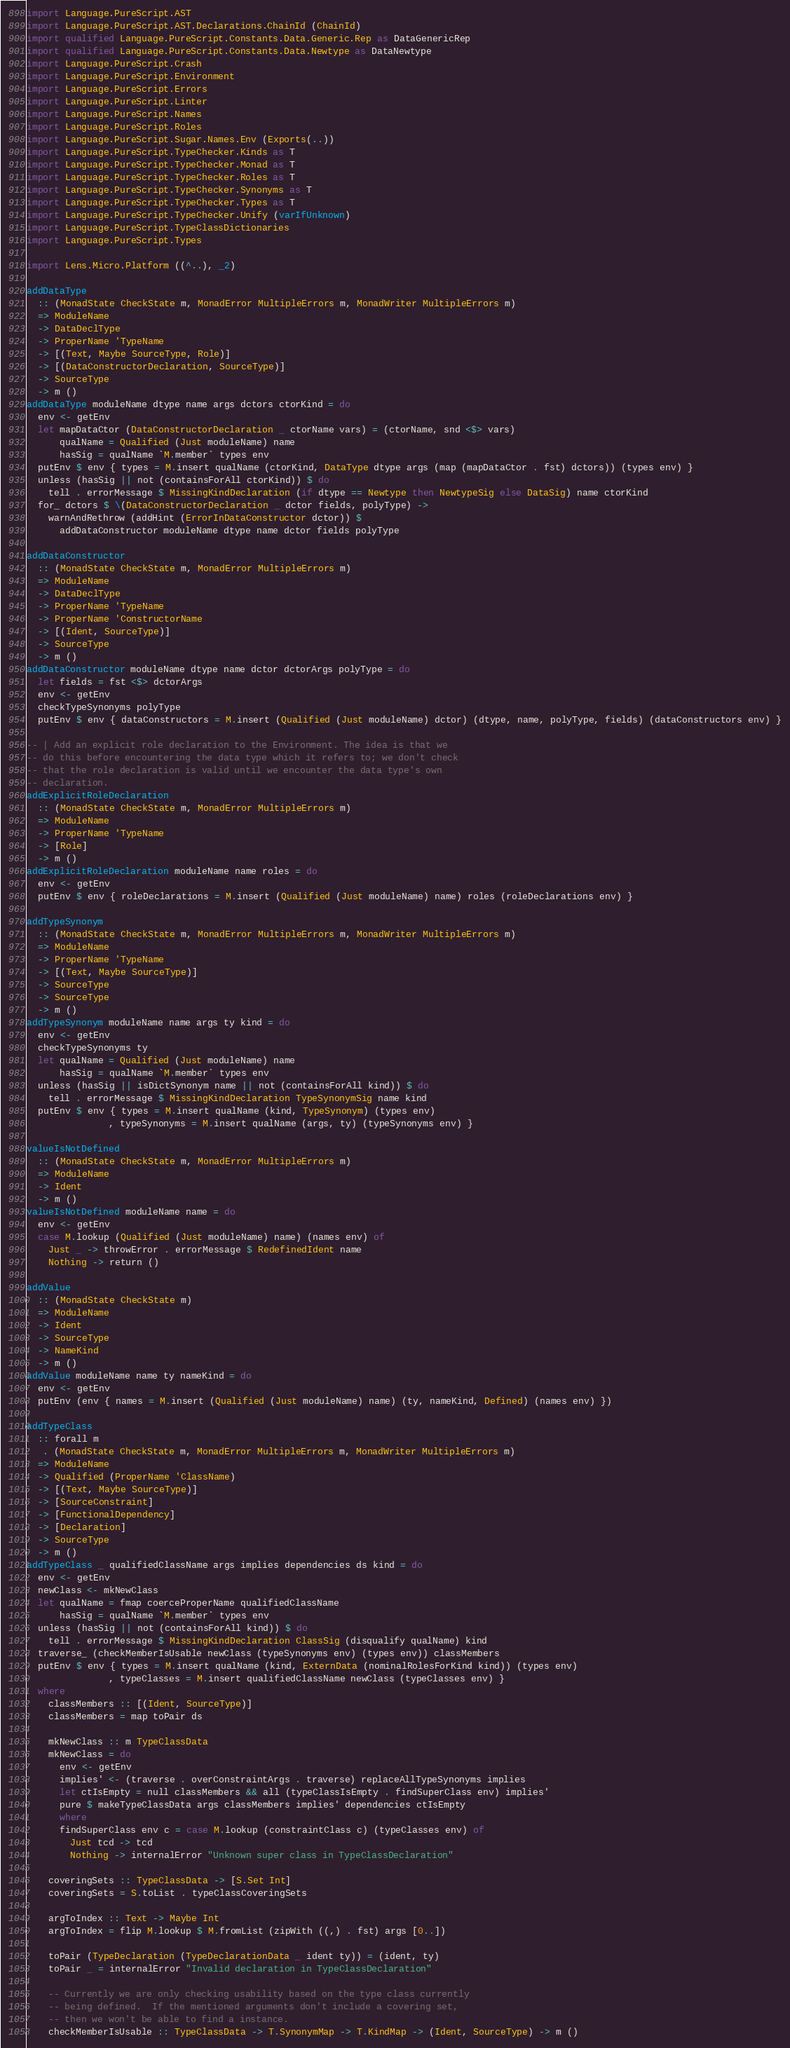<code> <loc_0><loc_0><loc_500><loc_500><_Haskell_>
import Language.PureScript.AST
import Language.PureScript.AST.Declarations.ChainId (ChainId)
import qualified Language.PureScript.Constants.Data.Generic.Rep as DataGenericRep
import qualified Language.PureScript.Constants.Data.Newtype as DataNewtype
import Language.PureScript.Crash
import Language.PureScript.Environment
import Language.PureScript.Errors
import Language.PureScript.Linter
import Language.PureScript.Names
import Language.PureScript.Roles
import Language.PureScript.Sugar.Names.Env (Exports(..))
import Language.PureScript.TypeChecker.Kinds as T
import Language.PureScript.TypeChecker.Monad as T
import Language.PureScript.TypeChecker.Roles as T
import Language.PureScript.TypeChecker.Synonyms as T
import Language.PureScript.TypeChecker.Types as T
import Language.PureScript.TypeChecker.Unify (varIfUnknown)
import Language.PureScript.TypeClassDictionaries
import Language.PureScript.Types

import Lens.Micro.Platform ((^..), _2)

addDataType
  :: (MonadState CheckState m, MonadError MultipleErrors m, MonadWriter MultipleErrors m)
  => ModuleName
  -> DataDeclType
  -> ProperName 'TypeName
  -> [(Text, Maybe SourceType, Role)]
  -> [(DataConstructorDeclaration, SourceType)]
  -> SourceType
  -> m ()
addDataType moduleName dtype name args dctors ctorKind = do
  env <- getEnv
  let mapDataCtor (DataConstructorDeclaration _ ctorName vars) = (ctorName, snd <$> vars)
      qualName = Qualified (Just moduleName) name
      hasSig = qualName `M.member` types env
  putEnv $ env { types = M.insert qualName (ctorKind, DataType dtype args (map (mapDataCtor . fst) dctors)) (types env) }
  unless (hasSig || not (containsForAll ctorKind)) $ do
    tell . errorMessage $ MissingKindDeclaration (if dtype == Newtype then NewtypeSig else DataSig) name ctorKind
  for_ dctors $ \(DataConstructorDeclaration _ dctor fields, polyType) ->
    warnAndRethrow (addHint (ErrorInDataConstructor dctor)) $
      addDataConstructor moduleName dtype name dctor fields polyType

addDataConstructor
  :: (MonadState CheckState m, MonadError MultipleErrors m)
  => ModuleName
  -> DataDeclType
  -> ProperName 'TypeName
  -> ProperName 'ConstructorName
  -> [(Ident, SourceType)]
  -> SourceType
  -> m ()
addDataConstructor moduleName dtype name dctor dctorArgs polyType = do
  let fields = fst <$> dctorArgs
  env <- getEnv
  checkTypeSynonyms polyType
  putEnv $ env { dataConstructors = M.insert (Qualified (Just moduleName) dctor) (dtype, name, polyType, fields) (dataConstructors env) }

-- | Add an explicit role declaration to the Environment. The idea is that we
-- do this before encountering the data type which it refers to; we don't check
-- that the role declaration is valid until we encounter the data type's own
-- declaration.
addExplicitRoleDeclaration
  :: (MonadState CheckState m, MonadError MultipleErrors m)
  => ModuleName
  -> ProperName 'TypeName
  -> [Role]
  -> m ()
addExplicitRoleDeclaration moduleName name roles = do
  env <- getEnv
  putEnv $ env { roleDeclarations = M.insert (Qualified (Just moduleName) name) roles (roleDeclarations env) }

addTypeSynonym
  :: (MonadState CheckState m, MonadError MultipleErrors m, MonadWriter MultipleErrors m)
  => ModuleName
  -> ProperName 'TypeName
  -> [(Text, Maybe SourceType)]
  -> SourceType
  -> SourceType
  -> m ()
addTypeSynonym moduleName name args ty kind = do
  env <- getEnv
  checkTypeSynonyms ty
  let qualName = Qualified (Just moduleName) name
      hasSig = qualName `M.member` types env
  unless (hasSig || isDictSynonym name || not (containsForAll kind)) $ do
    tell . errorMessage $ MissingKindDeclaration TypeSynonymSig name kind
  putEnv $ env { types = M.insert qualName (kind, TypeSynonym) (types env)
               , typeSynonyms = M.insert qualName (args, ty) (typeSynonyms env) }

valueIsNotDefined
  :: (MonadState CheckState m, MonadError MultipleErrors m)
  => ModuleName
  -> Ident
  -> m ()
valueIsNotDefined moduleName name = do
  env <- getEnv
  case M.lookup (Qualified (Just moduleName) name) (names env) of
    Just _ -> throwError . errorMessage $ RedefinedIdent name
    Nothing -> return ()

addValue
  :: (MonadState CheckState m)
  => ModuleName
  -> Ident
  -> SourceType
  -> NameKind
  -> m ()
addValue moduleName name ty nameKind = do
  env <- getEnv
  putEnv (env { names = M.insert (Qualified (Just moduleName) name) (ty, nameKind, Defined) (names env) })

addTypeClass
  :: forall m
   . (MonadState CheckState m, MonadError MultipleErrors m, MonadWriter MultipleErrors m)
  => ModuleName
  -> Qualified (ProperName 'ClassName)
  -> [(Text, Maybe SourceType)]
  -> [SourceConstraint]
  -> [FunctionalDependency]
  -> [Declaration]
  -> SourceType
  -> m ()
addTypeClass _ qualifiedClassName args implies dependencies ds kind = do
  env <- getEnv
  newClass <- mkNewClass
  let qualName = fmap coerceProperName qualifiedClassName
      hasSig = qualName `M.member` types env
  unless (hasSig || not (containsForAll kind)) $ do
    tell . errorMessage $ MissingKindDeclaration ClassSig (disqualify qualName) kind
  traverse_ (checkMemberIsUsable newClass (typeSynonyms env) (types env)) classMembers
  putEnv $ env { types = M.insert qualName (kind, ExternData (nominalRolesForKind kind)) (types env)
               , typeClasses = M.insert qualifiedClassName newClass (typeClasses env) }
  where
    classMembers :: [(Ident, SourceType)]
    classMembers = map toPair ds

    mkNewClass :: m TypeClassData
    mkNewClass = do
      env <- getEnv
      implies' <- (traverse . overConstraintArgs . traverse) replaceAllTypeSynonyms implies
      let ctIsEmpty = null classMembers && all (typeClassIsEmpty . findSuperClass env) implies'
      pure $ makeTypeClassData args classMembers implies' dependencies ctIsEmpty
      where
      findSuperClass env c = case M.lookup (constraintClass c) (typeClasses env) of
        Just tcd -> tcd
        Nothing -> internalError "Unknown super class in TypeClassDeclaration"

    coveringSets :: TypeClassData -> [S.Set Int]
    coveringSets = S.toList . typeClassCoveringSets

    argToIndex :: Text -> Maybe Int
    argToIndex = flip M.lookup $ M.fromList (zipWith ((,) . fst) args [0..])

    toPair (TypeDeclaration (TypeDeclarationData _ ident ty)) = (ident, ty)
    toPair _ = internalError "Invalid declaration in TypeClassDeclaration"

    -- Currently we are only checking usability based on the type class currently
    -- being defined.  If the mentioned arguments don't include a covering set,
    -- then we won't be able to find a instance.
    checkMemberIsUsable :: TypeClassData -> T.SynonymMap -> T.KindMap -> (Ident, SourceType) -> m ()</code> 